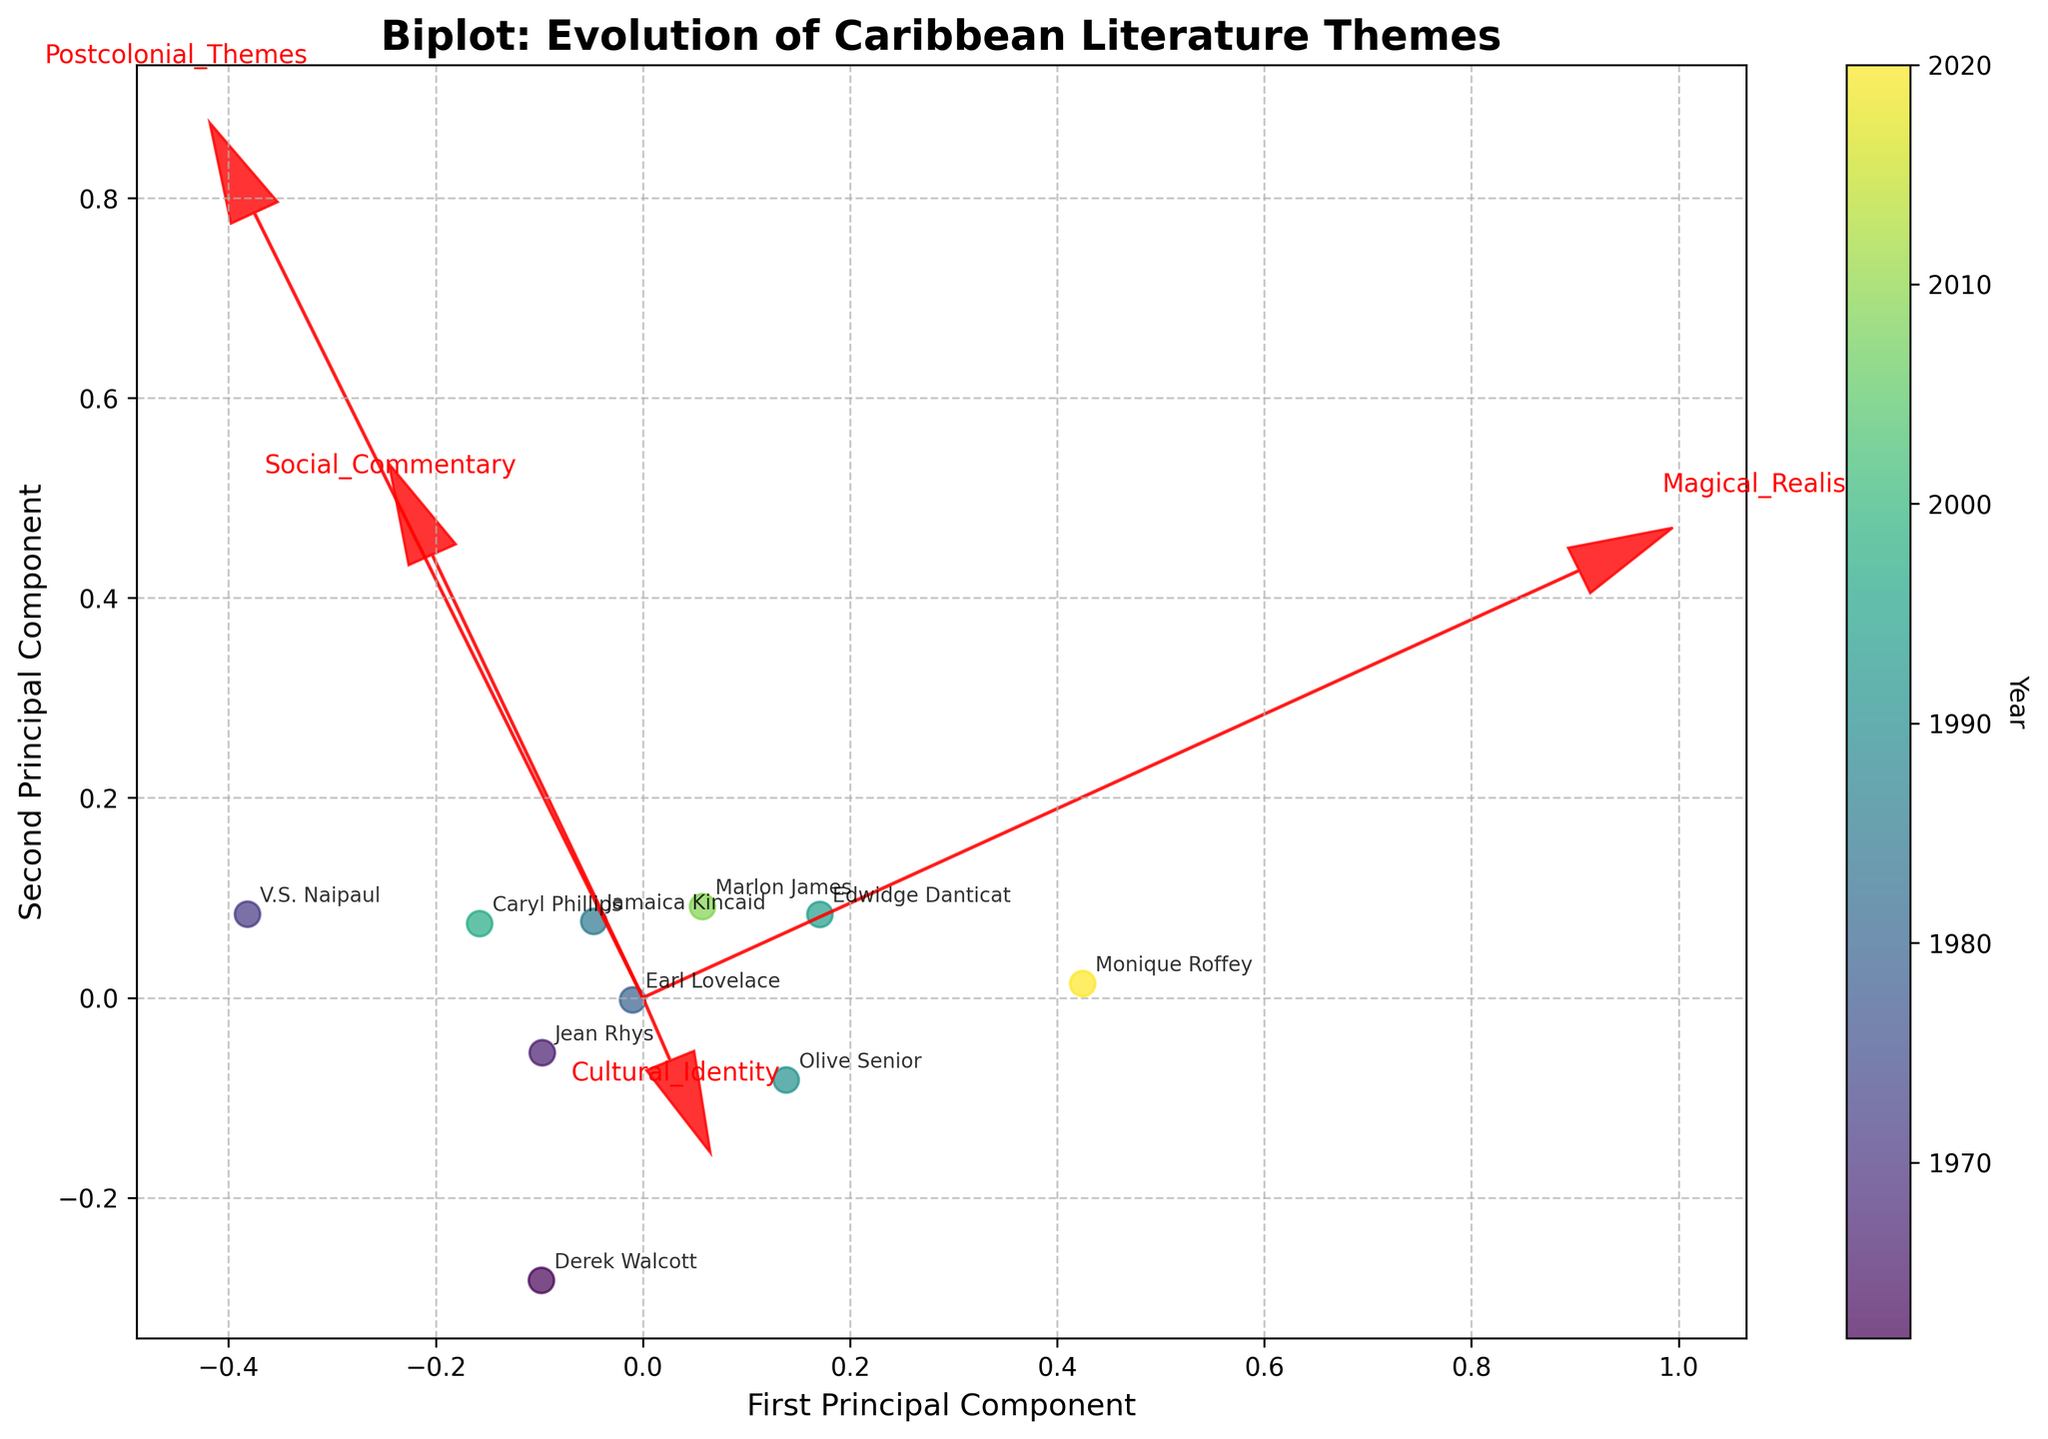Which author features the highest emphasis on Postcolonial Themes? From the figure, locate the vectors representing Postcolonial Themes and find which author lies closest to the end of that vector. The closest author to the Postcolonial Themes vector will have the highest emphasis.
Answer: Caryl Phillips Which year does the author with the highest use of Magical Realism represent? Identify the author with the highest value for Magical Realism by locating the authors closest to the vector pointing in the direction of high Magical Realism. Then use the color gradient to determine the year.
Answer: Monique Roffey Among the authors, who has the highest combined emphasis on Social Commentary and Cultural Identity? Find the authors' positions along the vectors of Social Commentary and Cultural Identity. Calculate the sum of the values from the PCA plot's coordinates for both dimensions and identify the author with the highest sum.
Answer: Edwidge Danticat Which author represents the earliest year in the plot? Examine the color gradient (legend in the side) to identify which color corresponds to the earliest year. Then find the author associated with that color.
Answer: Derek Walcott How does the emphasis on Social Commentary compare between Derek Walcott and Marlon James? Locate the positions of Derek Walcott and Marlon James on the PCA plot and observe their proximity to the Social Commentary vector. Marlon James, closer to the end of the vector, implies higher emphasis.
Answer: Marlon James has higher emphasis Which author from the 1960s focuses the most on Cultural Identity? Identify authors from the 1960s using the color gradient legend. Then observe their positions relative to the Cultural Identity vector.
Answer: Jean Rhys What is the relationship between Postcolonial Themes and Magical Realism in the evolution of Caribbean literature? Look at the directions of the vectors representing Postcolonial Themes and Magical Realism. Their relative positioning indicates whether there is a positive or negative correlation.
Answer: Weak positive relationship Considering the main themes, is there any author who stands out as a generalist with a balanced emphasis? Look for an author whose position is relatively equidistant from all thematic vectors, implying an even emphasis across different themes.
Answer: Olive Senior Who are the authors closest to each other on the PCA plot, suggesting similar thematic emphasis in their works? Compare distances between different authors' data points on the PCA plot. Authors located close to each other likely have similar thematic emphasis.
Answer: Derek Walcott and Caryl Phillips 